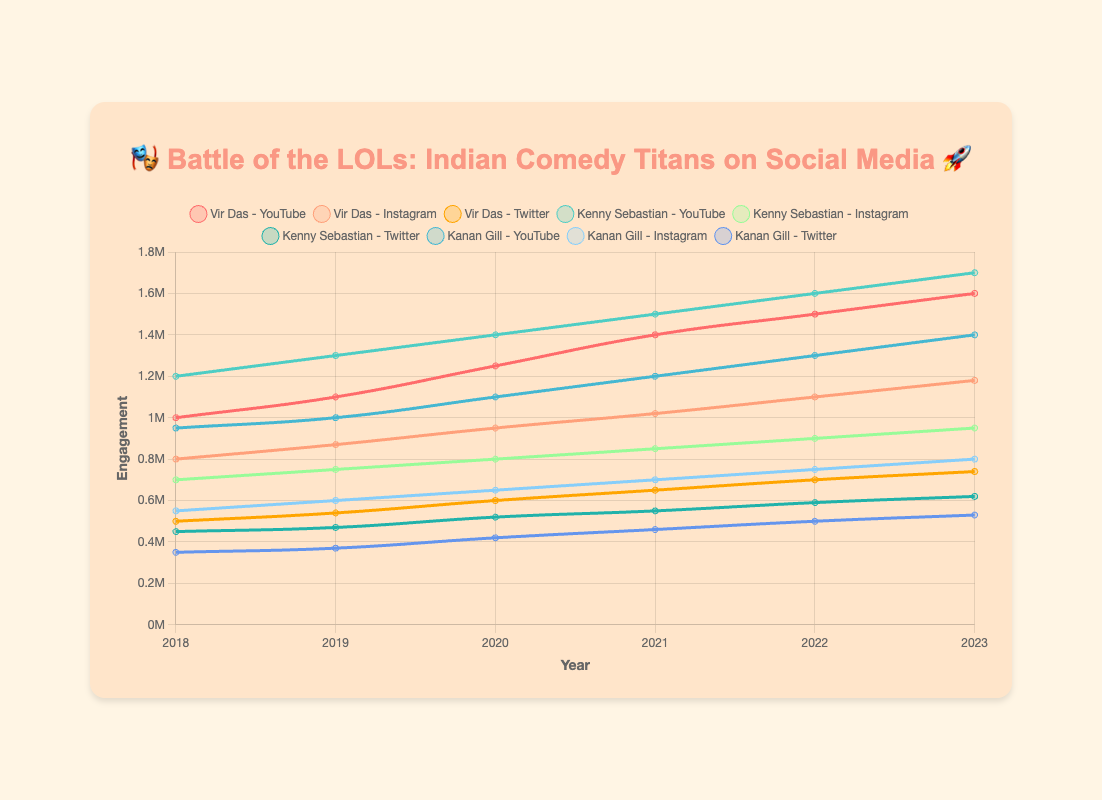What has been the trend in YouTube engagement for Vir Das from 2018 to 2023? We look at the line representing Vir Das on YouTube, observing the engagement levels from 2018 to 2023. There is a steady increase each year, starting from 1,000,000 in 2018 to 1,600,000 in 2023.
Answer: Steadily increasing Which platform does Kenny Sebastian have the highest engagement on in 2023? We locate the lines for Kenny Sebastian across YouTube, Instagram, and Twitter in 2023. The highest point is on YouTube at 1,700,000 engagements.
Answer: YouTube How did Kanan Gill's Twitter engagement change from 2018 to 2023? Checking the line for Kanan Gill on Twitter, we observe the engagement values: from 350,000 in 2018 to 530,000 in 2023, which shows a gradual increase over the years.
Answer: Gradually increased Which comedian had the highest Instagram engagement in 2021? Identifying the lines for each comedian on Instagram for 2021, Vir Das has the highest Instagram engagement at 1,020,000.
Answer: Vir Das Compare the growth of Instagram engagement for Vir Das and Kenny Sebastian from 2018 to 2023. Subtract 2018 engagements from 2023 engagements for both: Vir Das (1,180,000 - 800,000 = 380,000), Kenny Sebastian (950,000 - 700,000 = 250,000). Vir Das had a higher growth.
Answer: Vir Das Which comedian had the least YouTube engagement growth from 2018 to 2023? Calculating the growth by subtracting 2018 from 2023 engagements for all comedians on YouTube: Vir Das (600,000), Kenny Sebastian (500,000), Kanan Gill (450,000). Kanan Gill had the least growth.
Answer: Kanan Gill What is the average Twitter engagement for Vir Das over the five years? Adding Twitter engagements for Vir Das from 2018 to 2023: (500,000 + 540,000 + 600,000 + 650,000 + 700,000 + 740,000) = 3,730,000; divide by the number of years (6): 3,730,000 / 6 = 621,667.
Answer: 621,667 How did the engagement trends of Kenny Sebastian and Kanan Gill on YouTube differ from 2019 to 2023? Observing the lines from 2019 to 2023: Kenny Sebastian's engagement increased each year from 1,300,000 to 1,700,000, while Kanan Gill's engagement also increased but not linearly: from 1,000,000 to 1,400,000 with slight variations.
Answer: Different growth patterns What was the difference in Instagram engagement between Kanan Gill and Kenny Sebastian in 2020? Subtracting Kenny Sebastian's 2020 Instagram engagement (800,000) from Kanan Gill’s (650,000) gives 800,000 - 650,000 = 150,000.
Answer: 150,000 